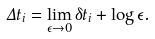Convert formula to latex. <formula><loc_0><loc_0><loc_500><loc_500>\Delta t _ { i } = \lim _ { \epsilon \to 0 } \delta t _ { i } + \log \epsilon .</formula> 